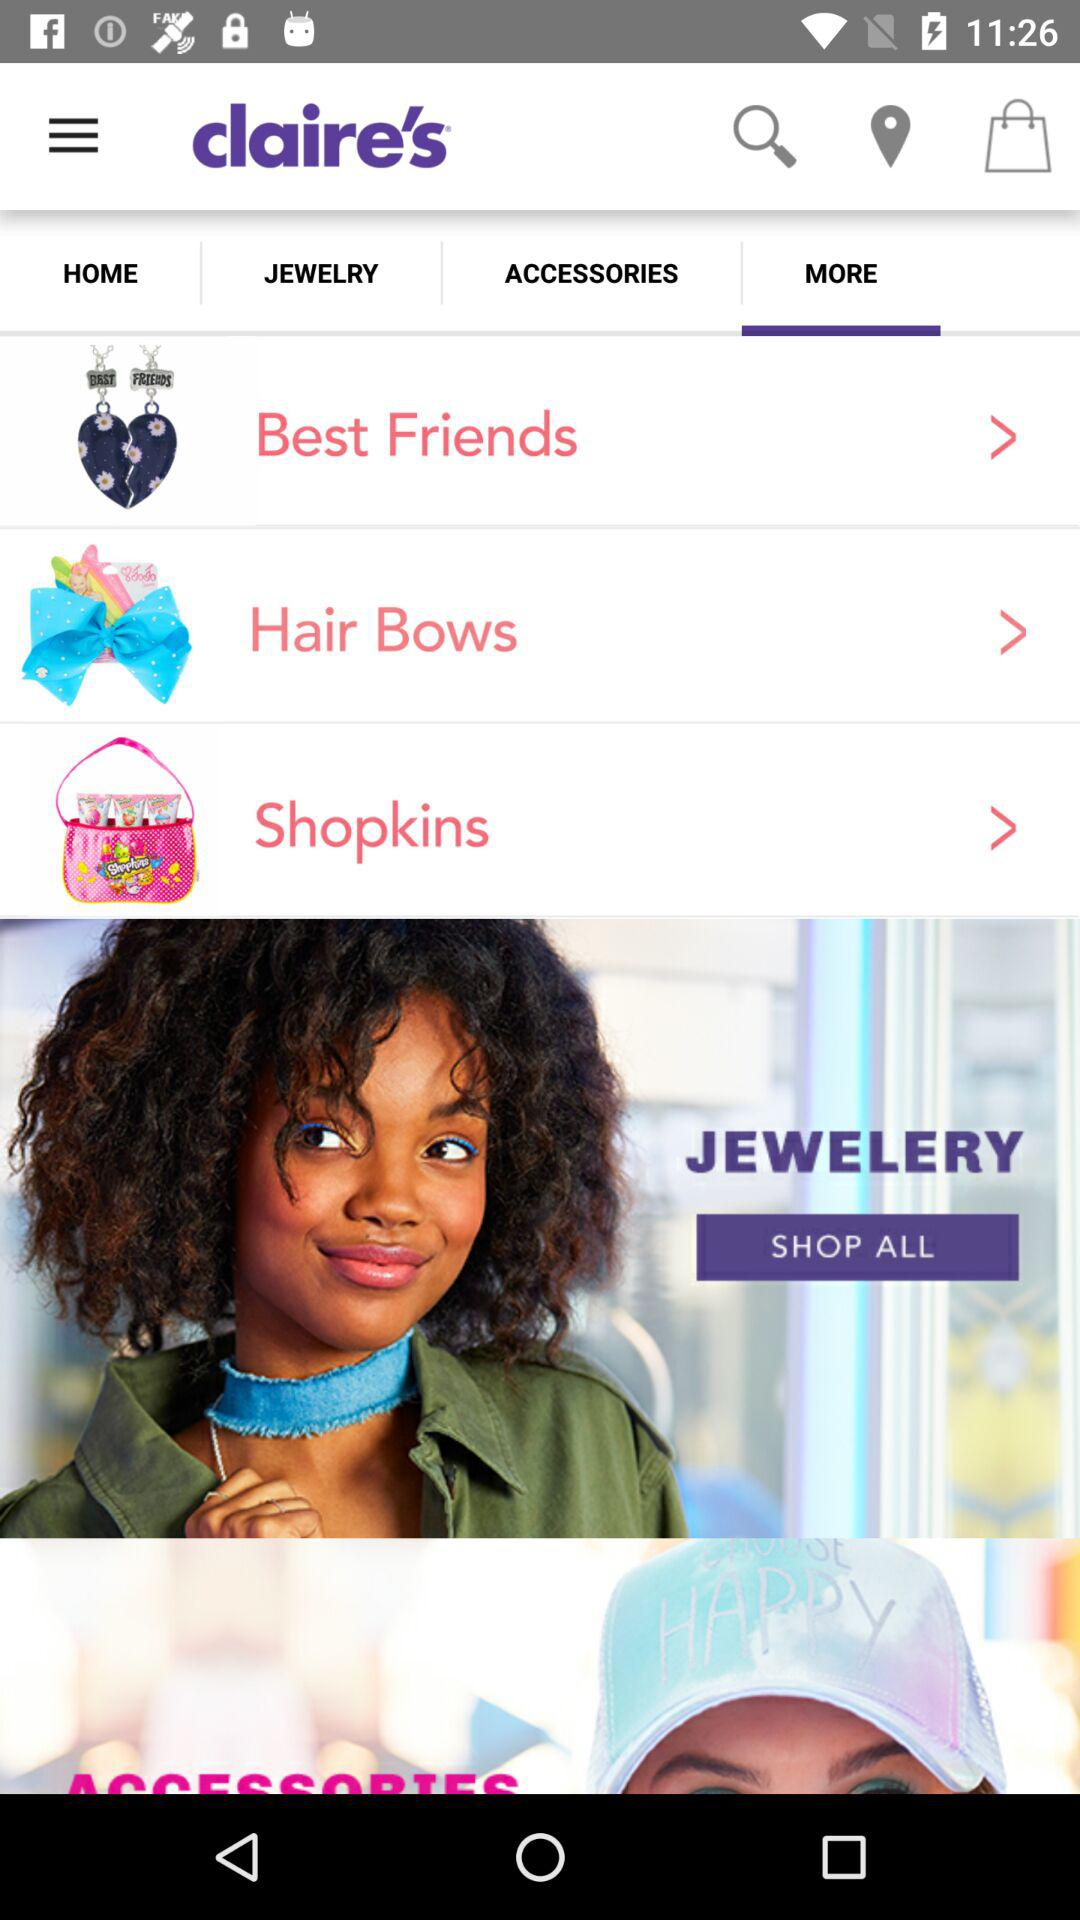Which tab is currently selected? The currently selected tab is "MORE". 